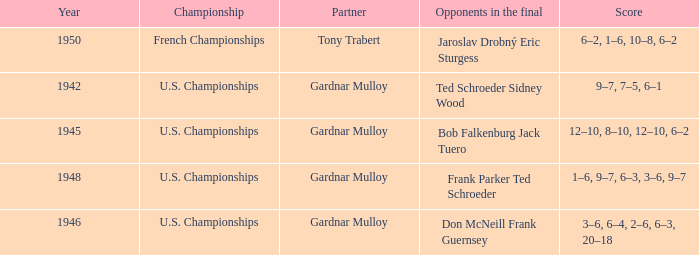Which opponents in the u.s. championships played after 1945 and had a score of 3–6, 6–4, 2–6, 6–3, 20–18? Don McNeill Frank Guernsey. 